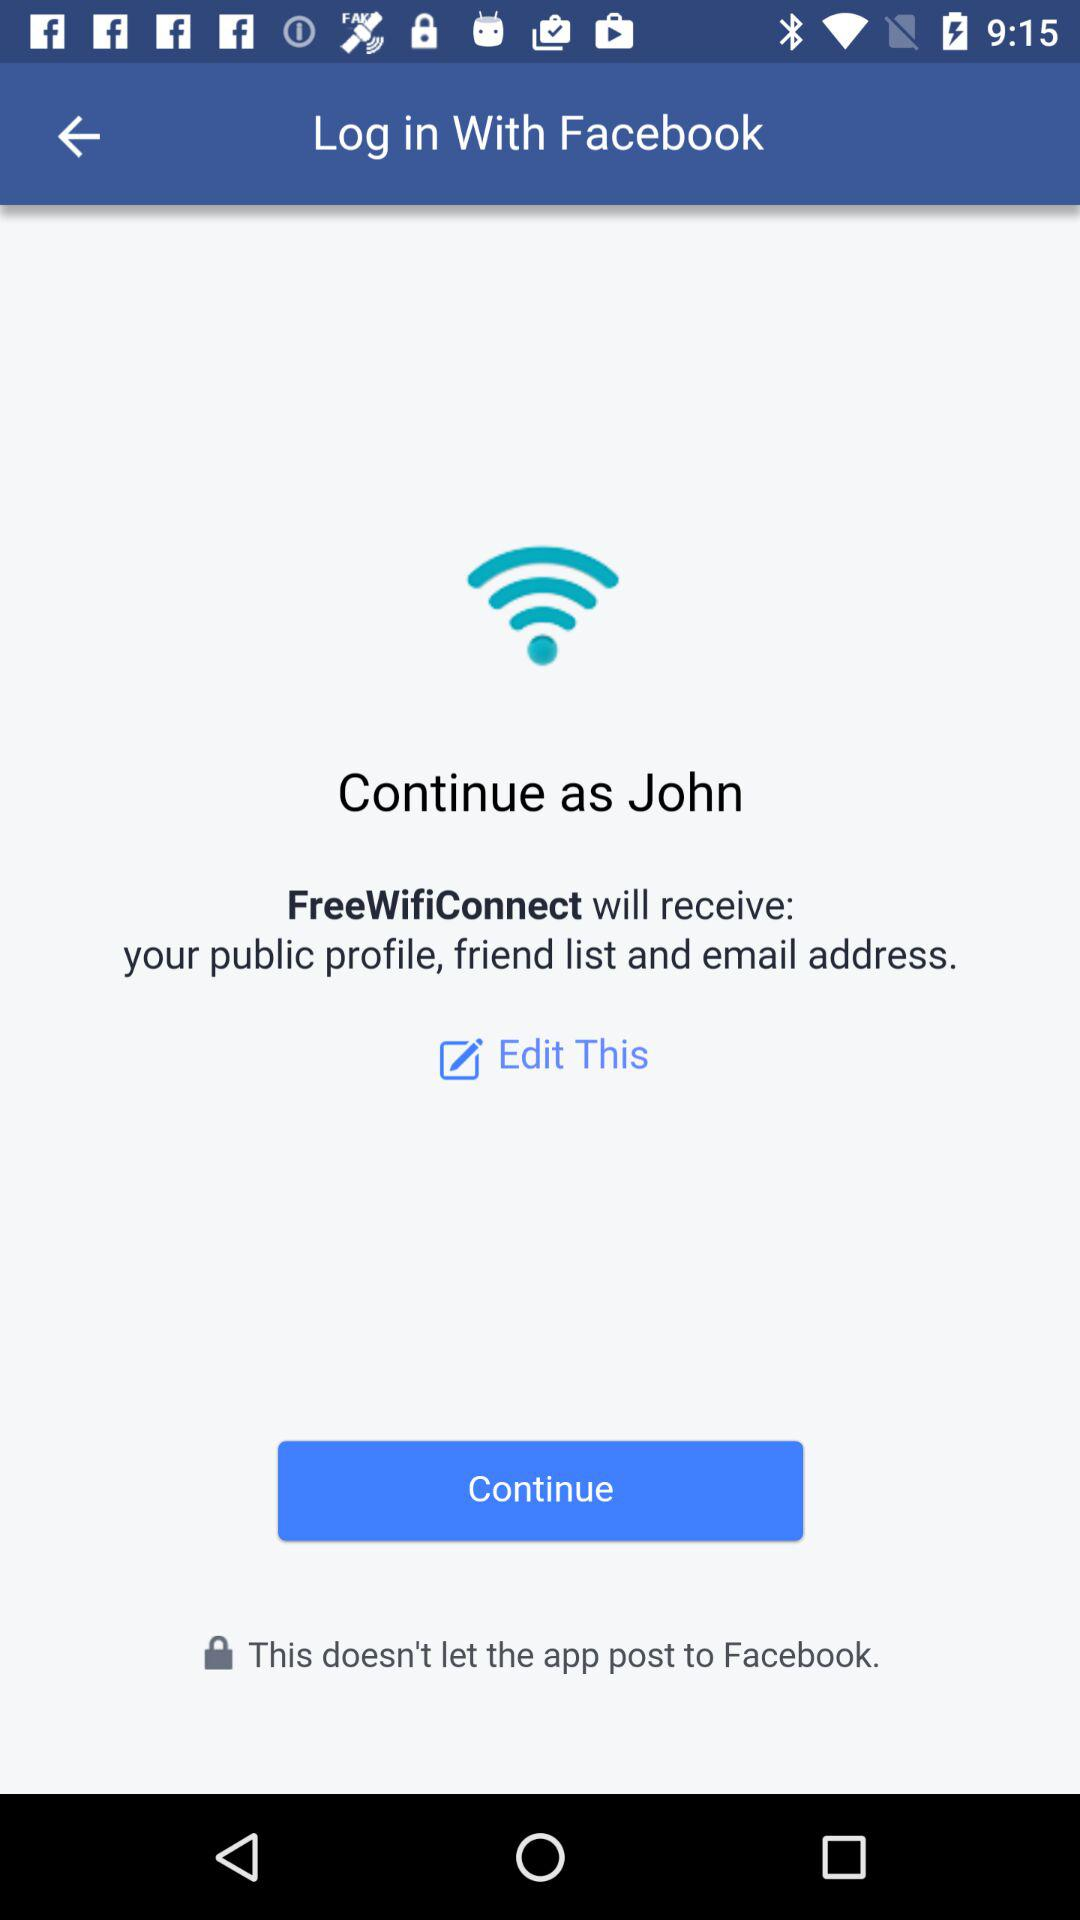What application can be used to log in? The application that can be used to log in is "Facebook". 